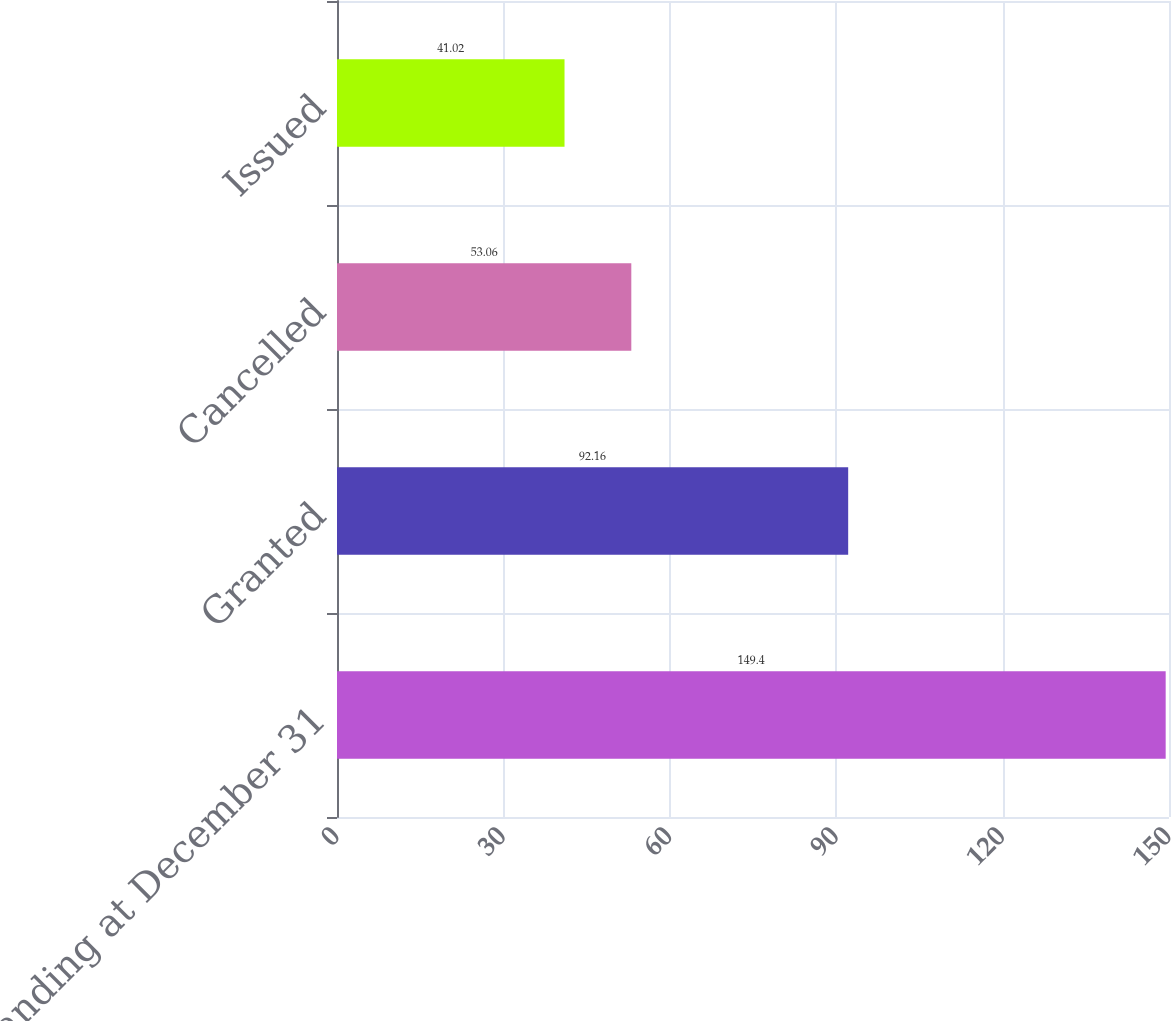Convert chart. <chart><loc_0><loc_0><loc_500><loc_500><bar_chart><fcel>Outstanding at December 31<fcel>Granted<fcel>Cancelled<fcel>Issued<nl><fcel>149.4<fcel>92.16<fcel>53.06<fcel>41.02<nl></chart> 